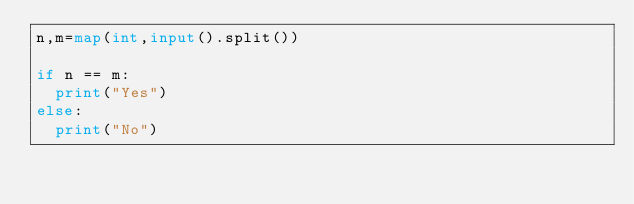Convert code to text. <code><loc_0><loc_0><loc_500><loc_500><_Python_>n,m=map(int,input().split())

if n == m:
  print("Yes")
else:
  print("No")</code> 